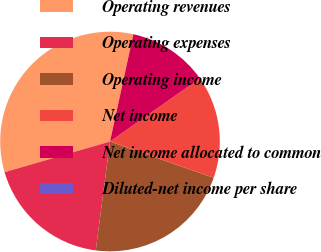Convert chart to OTSL. <chart><loc_0><loc_0><loc_500><loc_500><pie_chart><fcel>Operating revenues<fcel>Operating expenses<fcel>Operating income<fcel>Net income<fcel>Net income allocated to common<fcel>Diluted-net income per share<nl><fcel>32.92%<fcel>18.42%<fcel>21.71%<fcel>15.12%<fcel>11.83%<fcel>0.0%<nl></chart> 